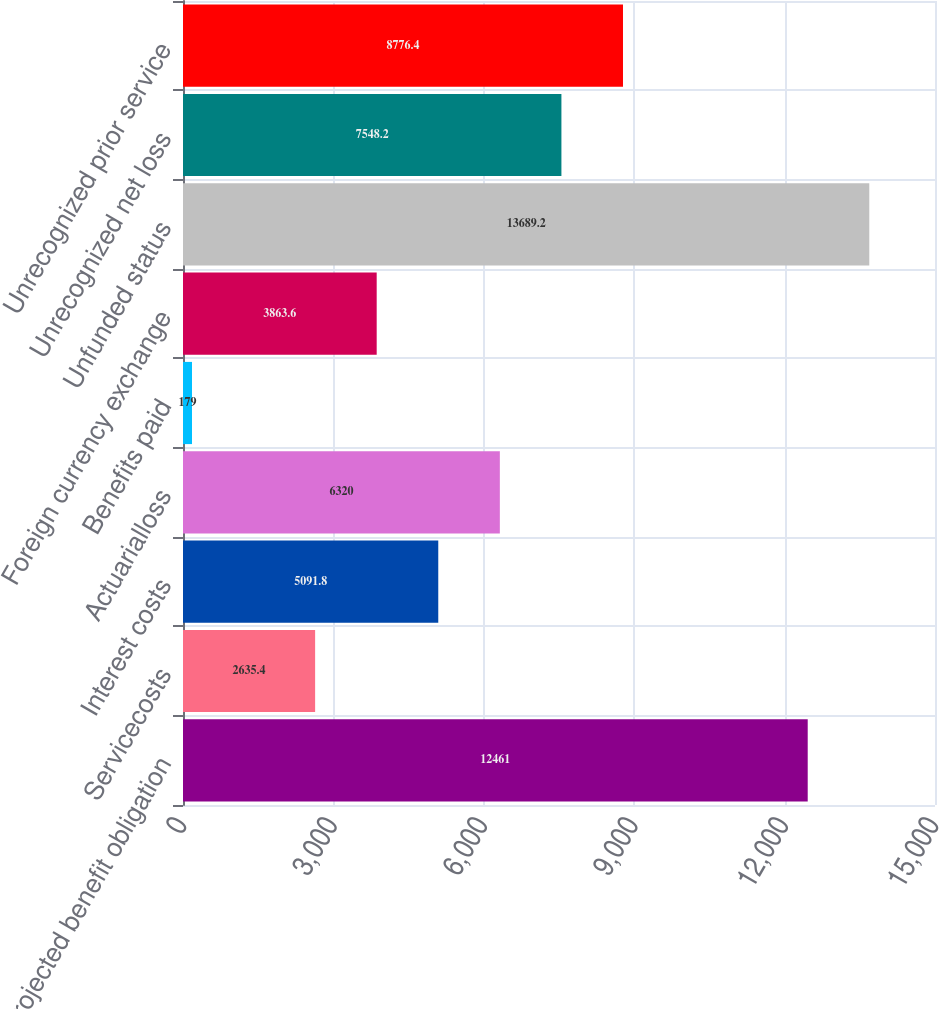<chart> <loc_0><loc_0><loc_500><loc_500><bar_chart><fcel>Projected benefit obligation<fcel>Servicecosts<fcel>Interest costs<fcel>Actuarialloss<fcel>Benefits paid<fcel>Foreign currency exchange<fcel>Unfunded status<fcel>Unrecognized net loss<fcel>Unrecognized prior service<nl><fcel>12461<fcel>2635.4<fcel>5091.8<fcel>6320<fcel>179<fcel>3863.6<fcel>13689.2<fcel>7548.2<fcel>8776.4<nl></chart> 